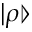<formula> <loc_0><loc_0><loc_500><loc_500>| \rho \ r r a n g l e</formula> 